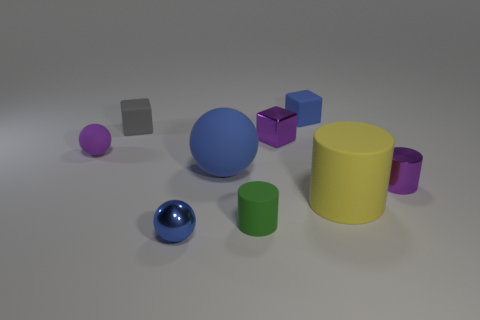What number of objects are either cylinders in front of the small purple shiny cylinder or small green cylinders that are right of the small purple matte ball?
Keep it short and to the point. 2. What number of other things are the same color as the small metallic sphere?
Provide a short and direct response. 2. There is a small purple matte thing; is it the same shape as the large matte object behind the metal cylinder?
Make the answer very short. Yes. Are there fewer small matte balls right of the shiny cube than rubber objects behind the big rubber cylinder?
Your response must be concise. Yes. There is a small purple thing that is the same shape as the yellow rubber object; what is its material?
Keep it short and to the point. Metal. Does the large cylinder have the same color as the large rubber ball?
Make the answer very short. No. What shape is the tiny blue thing that is made of the same material as the gray block?
Keep it short and to the point. Cube. How many other big yellow things are the same shape as the yellow rubber object?
Keep it short and to the point. 0. What is the shape of the big object right of the cylinder left of the small purple cube?
Ensure brevity in your answer.  Cylinder. There is a purple rubber ball behind the green object; is its size the same as the small purple metallic cube?
Keep it short and to the point. Yes. 